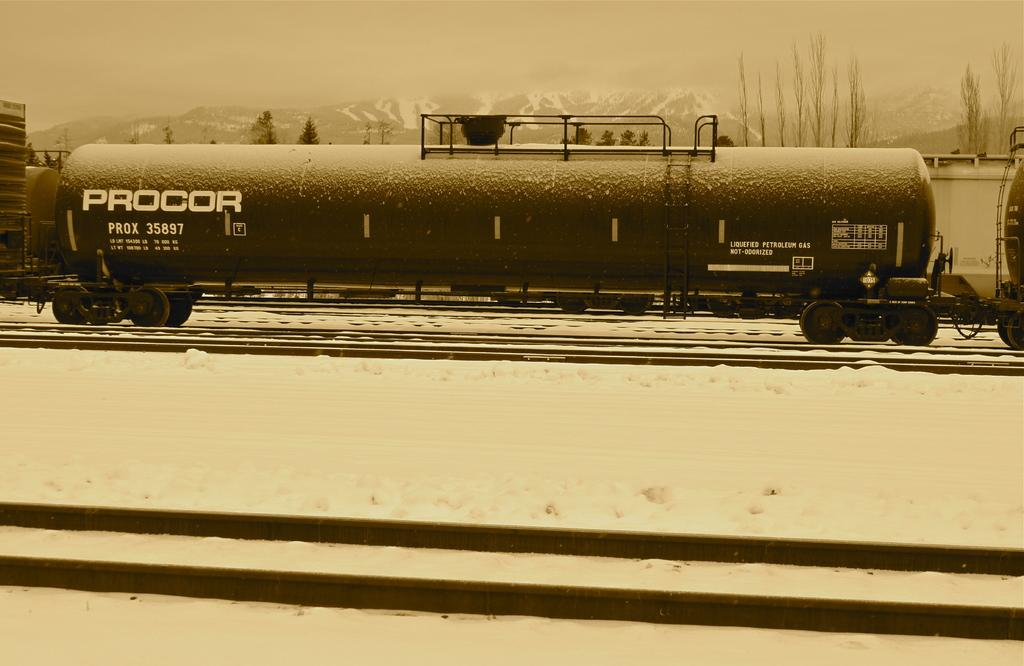What is the main subject of the image? The main subject of the image is a train. Where is the train located in the image? The train is on a railway track. What can be seen in the background of the image? There are trees, mountains, and snow visible in the background of the image. What type of flame can be seen coming from the ship in the image? There is no ship present in the image, and therefore no flame can be seen coming from it. 